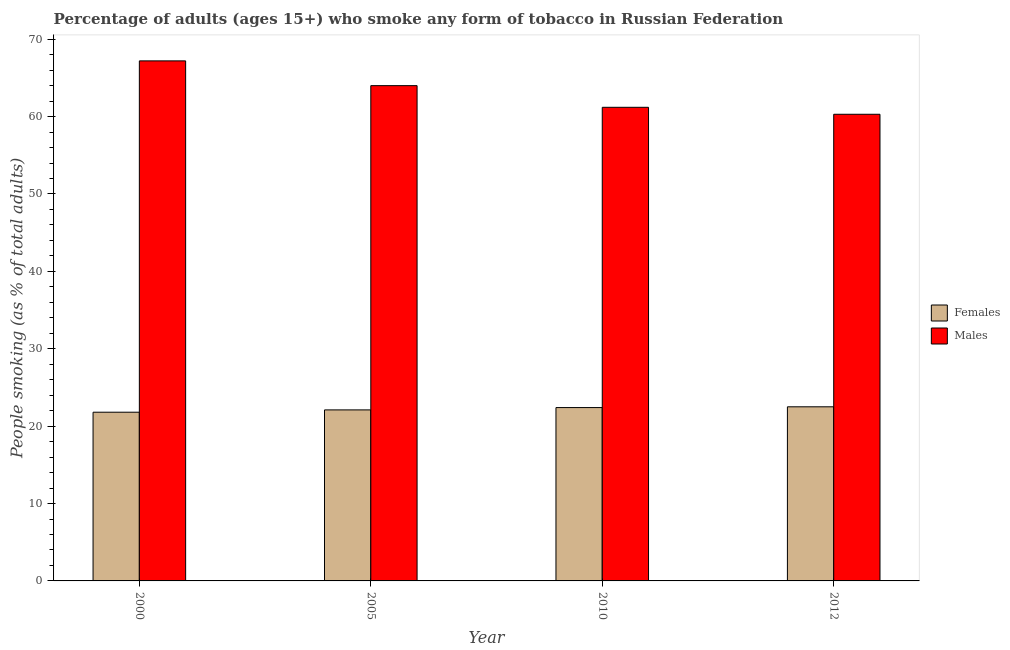How many different coloured bars are there?
Ensure brevity in your answer.  2. How many groups of bars are there?
Make the answer very short. 4. Are the number of bars per tick equal to the number of legend labels?
Provide a short and direct response. Yes. How many bars are there on the 3rd tick from the left?
Offer a terse response. 2. How many bars are there on the 1st tick from the right?
Make the answer very short. 2. What is the label of the 3rd group of bars from the left?
Keep it short and to the point. 2010. In how many cases, is the number of bars for a given year not equal to the number of legend labels?
Give a very brief answer. 0. What is the percentage of males who smoke in 2012?
Give a very brief answer. 60.3. Across all years, what is the minimum percentage of females who smoke?
Make the answer very short. 21.8. In which year was the percentage of males who smoke minimum?
Provide a succinct answer. 2012. What is the total percentage of females who smoke in the graph?
Offer a very short reply. 88.8. What is the difference between the percentage of females who smoke in 2000 and that in 2012?
Give a very brief answer. -0.7. What is the difference between the percentage of females who smoke in 2005 and the percentage of males who smoke in 2000?
Provide a short and direct response. 0.3. What is the average percentage of females who smoke per year?
Make the answer very short. 22.2. In how many years, is the percentage of males who smoke greater than 24 %?
Provide a succinct answer. 4. What is the ratio of the percentage of females who smoke in 2000 to that in 2005?
Give a very brief answer. 0.99. Is the percentage of females who smoke in 2005 less than that in 2012?
Your answer should be very brief. Yes. What is the difference between the highest and the second highest percentage of males who smoke?
Provide a short and direct response. 3.2. What is the difference between the highest and the lowest percentage of males who smoke?
Provide a succinct answer. 6.9. Is the sum of the percentage of females who smoke in 2000 and 2010 greater than the maximum percentage of males who smoke across all years?
Your answer should be compact. Yes. What does the 1st bar from the left in 2010 represents?
Your answer should be compact. Females. What does the 1st bar from the right in 2000 represents?
Your answer should be very brief. Males. What is the difference between two consecutive major ticks on the Y-axis?
Provide a succinct answer. 10. Are the values on the major ticks of Y-axis written in scientific E-notation?
Give a very brief answer. No. Where does the legend appear in the graph?
Offer a very short reply. Center right. How are the legend labels stacked?
Make the answer very short. Vertical. What is the title of the graph?
Your response must be concise. Percentage of adults (ages 15+) who smoke any form of tobacco in Russian Federation. What is the label or title of the Y-axis?
Your response must be concise. People smoking (as % of total adults). What is the People smoking (as % of total adults) of Females in 2000?
Keep it short and to the point. 21.8. What is the People smoking (as % of total adults) of Males in 2000?
Ensure brevity in your answer.  67.2. What is the People smoking (as % of total adults) of Females in 2005?
Give a very brief answer. 22.1. What is the People smoking (as % of total adults) of Males in 2005?
Keep it short and to the point. 64. What is the People smoking (as % of total adults) of Females in 2010?
Provide a short and direct response. 22.4. What is the People smoking (as % of total adults) in Males in 2010?
Your answer should be very brief. 61.2. What is the People smoking (as % of total adults) in Females in 2012?
Offer a very short reply. 22.5. What is the People smoking (as % of total adults) of Males in 2012?
Keep it short and to the point. 60.3. Across all years, what is the maximum People smoking (as % of total adults) of Males?
Provide a short and direct response. 67.2. Across all years, what is the minimum People smoking (as % of total adults) of Females?
Give a very brief answer. 21.8. Across all years, what is the minimum People smoking (as % of total adults) of Males?
Ensure brevity in your answer.  60.3. What is the total People smoking (as % of total adults) of Females in the graph?
Your answer should be compact. 88.8. What is the total People smoking (as % of total adults) of Males in the graph?
Give a very brief answer. 252.7. What is the difference between the People smoking (as % of total adults) in Females in 2000 and that in 2005?
Make the answer very short. -0.3. What is the difference between the People smoking (as % of total adults) in Females in 2000 and that in 2010?
Provide a short and direct response. -0.6. What is the difference between the People smoking (as % of total adults) in Females in 2005 and that in 2010?
Your answer should be very brief. -0.3. What is the difference between the People smoking (as % of total adults) in Males in 2005 and that in 2010?
Your answer should be compact. 2.8. What is the difference between the People smoking (as % of total adults) of Males in 2005 and that in 2012?
Give a very brief answer. 3.7. What is the difference between the People smoking (as % of total adults) in Males in 2010 and that in 2012?
Provide a short and direct response. 0.9. What is the difference between the People smoking (as % of total adults) in Females in 2000 and the People smoking (as % of total adults) in Males in 2005?
Provide a short and direct response. -42.2. What is the difference between the People smoking (as % of total adults) of Females in 2000 and the People smoking (as % of total adults) of Males in 2010?
Give a very brief answer. -39.4. What is the difference between the People smoking (as % of total adults) of Females in 2000 and the People smoking (as % of total adults) of Males in 2012?
Your answer should be compact. -38.5. What is the difference between the People smoking (as % of total adults) of Females in 2005 and the People smoking (as % of total adults) of Males in 2010?
Provide a short and direct response. -39.1. What is the difference between the People smoking (as % of total adults) in Females in 2005 and the People smoking (as % of total adults) in Males in 2012?
Offer a terse response. -38.2. What is the difference between the People smoking (as % of total adults) in Females in 2010 and the People smoking (as % of total adults) in Males in 2012?
Your response must be concise. -37.9. What is the average People smoking (as % of total adults) of Males per year?
Make the answer very short. 63.17. In the year 2000, what is the difference between the People smoking (as % of total adults) of Females and People smoking (as % of total adults) of Males?
Your response must be concise. -45.4. In the year 2005, what is the difference between the People smoking (as % of total adults) of Females and People smoking (as % of total adults) of Males?
Provide a succinct answer. -41.9. In the year 2010, what is the difference between the People smoking (as % of total adults) of Females and People smoking (as % of total adults) of Males?
Your answer should be compact. -38.8. In the year 2012, what is the difference between the People smoking (as % of total adults) in Females and People smoking (as % of total adults) in Males?
Provide a short and direct response. -37.8. What is the ratio of the People smoking (as % of total adults) of Females in 2000 to that in 2005?
Provide a short and direct response. 0.99. What is the ratio of the People smoking (as % of total adults) of Females in 2000 to that in 2010?
Your answer should be compact. 0.97. What is the ratio of the People smoking (as % of total adults) in Males in 2000 to that in 2010?
Your response must be concise. 1.1. What is the ratio of the People smoking (as % of total adults) of Females in 2000 to that in 2012?
Offer a terse response. 0.97. What is the ratio of the People smoking (as % of total adults) in Males in 2000 to that in 2012?
Ensure brevity in your answer.  1.11. What is the ratio of the People smoking (as % of total adults) in Females in 2005 to that in 2010?
Give a very brief answer. 0.99. What is the ratio of the People smoking (as % of total adults) of Males in 2005 to that in 2010?
Provide a succinct answer. 1.05. What is the ratio of the People smoking (as % of total adults) of Females in 2005 to that in 2012?
Offer a very short reply. 0.98. What is the ratio of the People smoking (as % of total adults) in Males in 2005 to that in 2012?
Offer a very short reply. 1.06. What is the ratio of the People smoking (as % of total adults) in Males in 2010 to that in 2012?
Provide a succinct answer. 1.01. What is the difference between the highest and the second highest People smoking (as % of total adults) in Females?
Provide a succinct answer. 0.1. What is the difference between the highest and the second highest People smoking (as % of total adults) in Males?
Give a very brief answer. 3.2. What is the difference between the highest and the lowest People smoking (as % of total adults) in Females?
Ensure brevity in your answer.  0.7. What is the difference between the highest and the lowest People smoking (as % of total adults) of Males?
Provide a short and direct response. 6.9. 